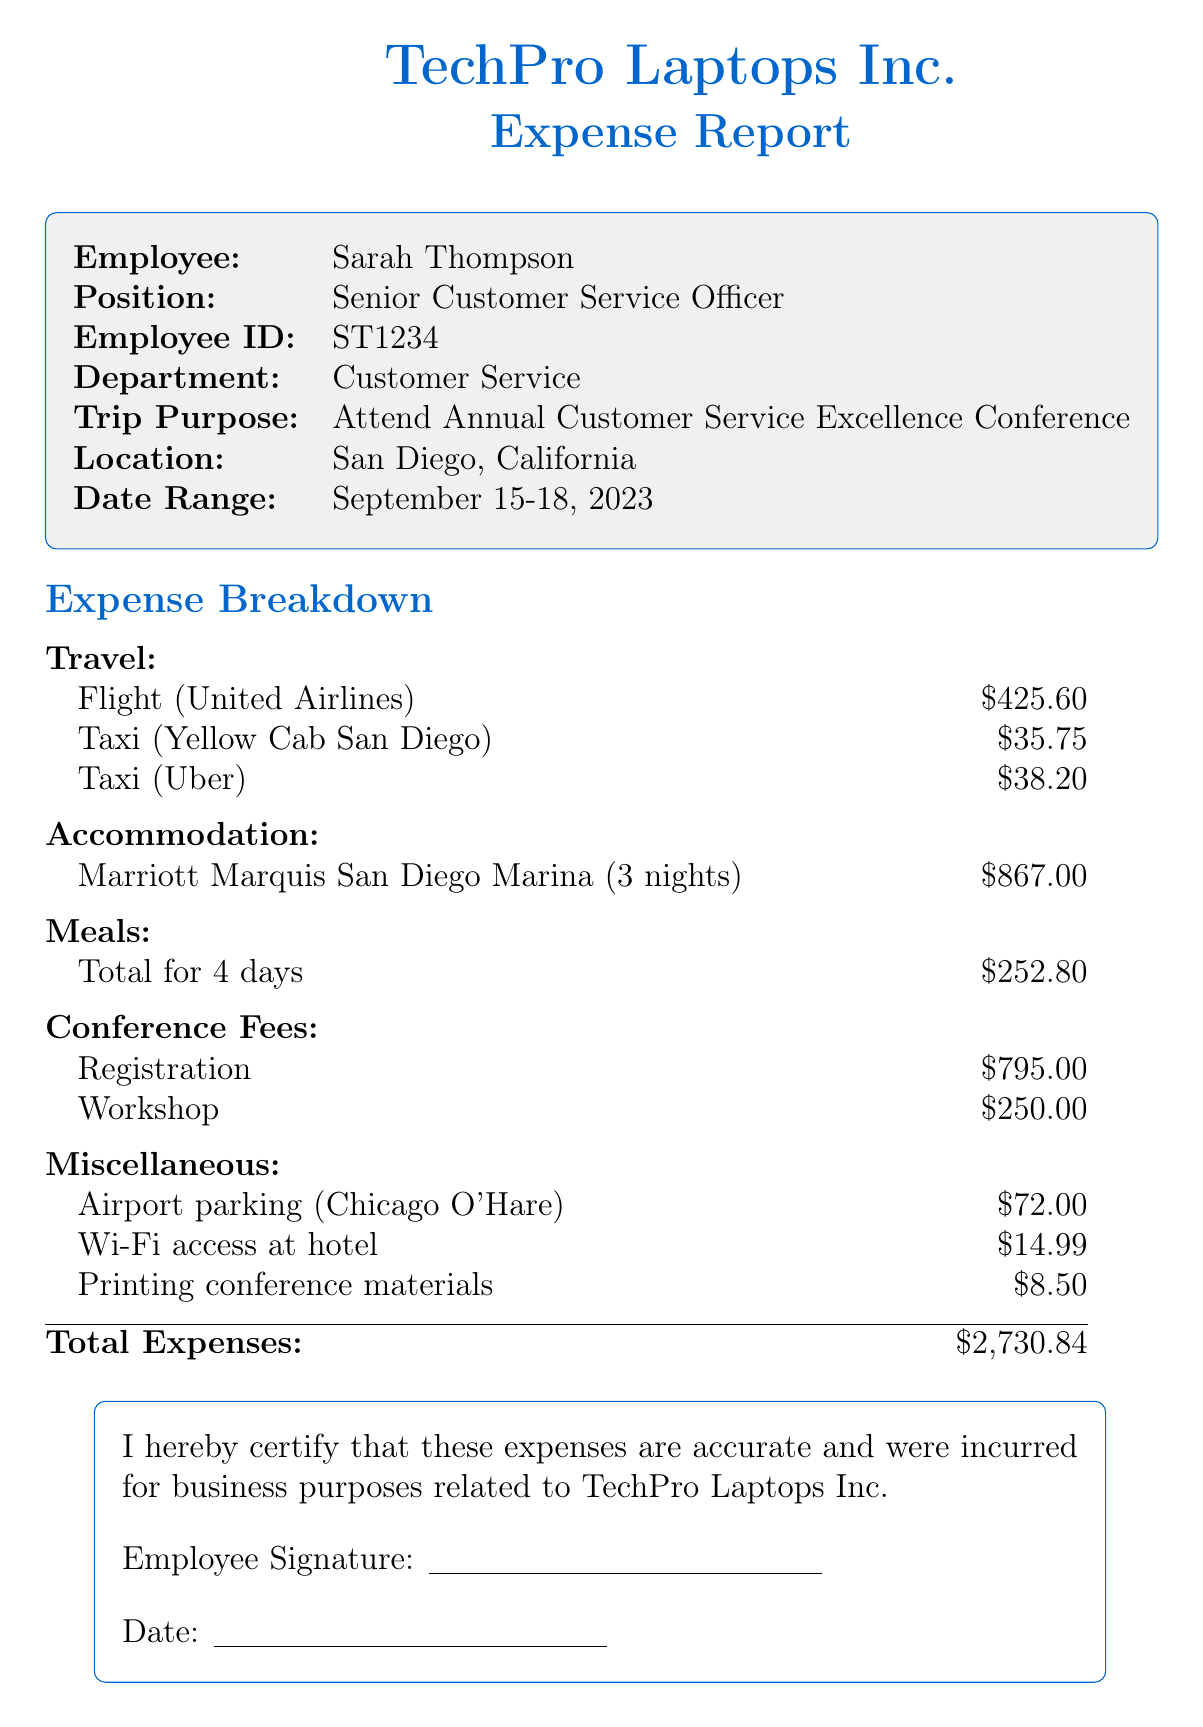what is the employee's name? The employee's name is listed at the beginning of the document as Sarah Thompson.
Answer: Sarah Thompson what is the total cost for accommodation? The total accommodation cost is provided in the accommodation section of the document as $867.00.
Answer: $867.00 how many nights did the employee stay at the hotel? The number of nights stayed at the hotel is specified as 3 nights in the accommodation section.
Answer: 3 what was the cost of the flight? The document states that the cost of the flight with United Airlines is $425.60.
Answer: $425.60 what conference did Sarah attend? The conference name is mentioned within the trip details as the SOCAP International Customer Care Conference.
Answer: SOCAP International Customer Care Conference what is the total for meal expenses? The total amount for meals is summarized in the meal section as $252.80.
Answer: $252.80 what is the registration fee for the conference? The registration fee for the conference is listed in the conference fees section as $795.00.
Answer: $795.00 how much did the airport parking cost? The cost of airport parking is noted in the miscellaneous expenses as $72.00.
Answer: $72.00 what is the purpose of the trip? The purpose of the trip is stated in the trip details as to attend the Annual Customer Service Excellence Conference.
Answer: Attend Annual Customer Service Excellence Conference 